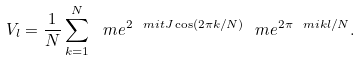<formula> <loc_0><loc_0><loc_500><loc_500>V _ { l } = \frac { 1 } { N } \sum _ { k = 1 } ^ { N } \ m e ^ { 2 \ m i t J \cos ( 2 \pi k / N ) } \ m e ^ { 2 \pi \ m i k l / N } .</formula> 